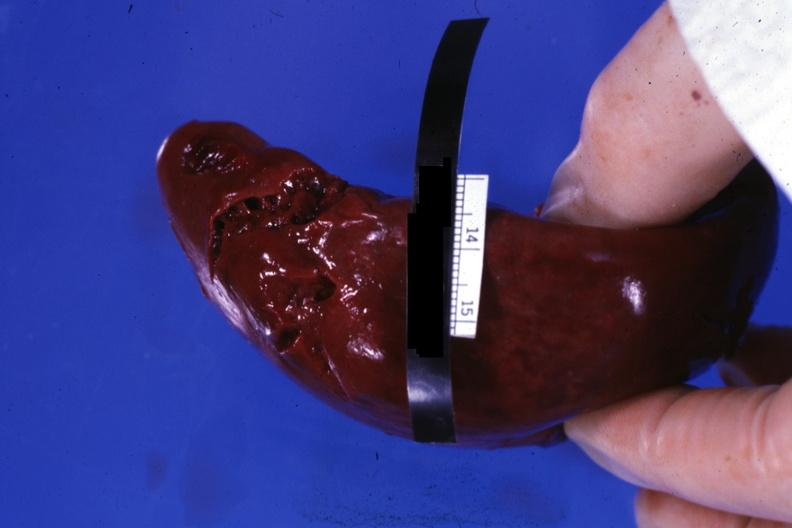s hematologic present?
Answer the question using a single word or phrase. Yes 